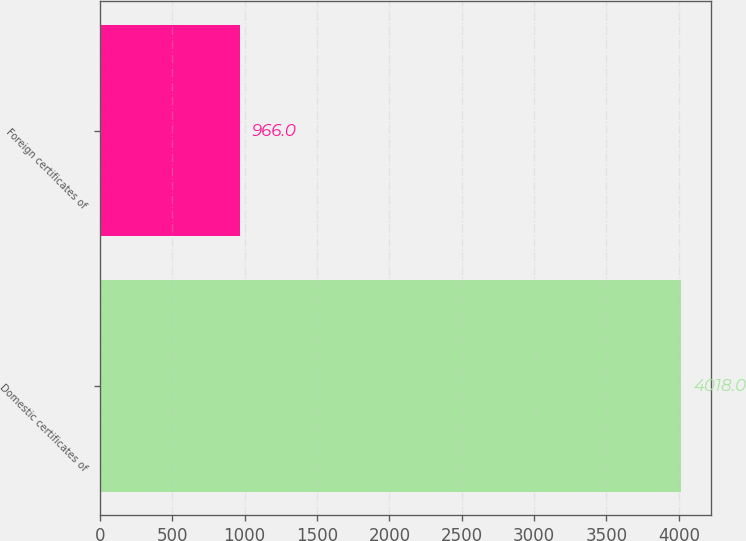Convert chart. <chart><loc_0><loc_0><loc_500><loc_500><bar_chart><fcel>Domestic certificates of<fcel>Foreign certificates of<nl><fcel>4018<fcel>966<nl></chart> 